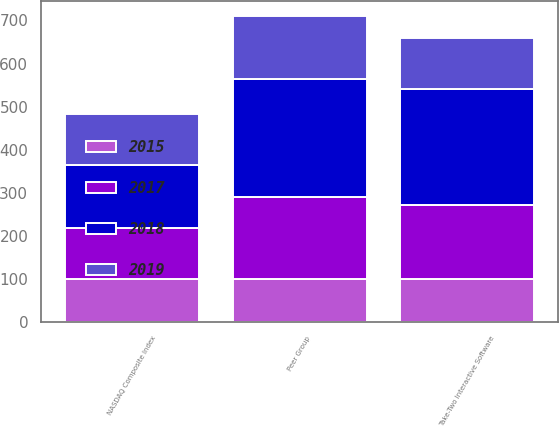Convert chart to OTSL. <chart><loc_0><loc_0><loc_500><loc_500><stacked_bar_chart><ecel><fcel>Take-Two Interactive Software<fcel>NASDAQ Composite Index<fcel>Peer Group<nl><fcel>2015<fcel>100<fcel>100<fcel>100<nl><fcel>2019<fcel>116.1<fcel>118.12<fcel>146.81<nl><fcel>2017<fcel>171.77<fcel>118.77<fcel>191.27<nl><fcel>2018<fcel>270.27<fcel>145.94<fcel>272.47<nl></chart> 